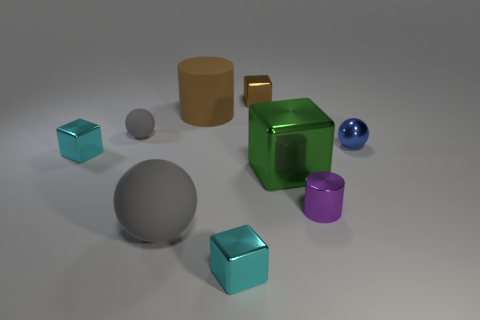Are there fewer brown cubes behind the tiny brown metallic block than green metal cubes?
Offer a very short reply. Yes. What number of tiny metal objects are the same color as the large cube?
Provide a short and direct response. 0. What is the size of the cyan block behind the small purple metal cylinder?
Ensure brevity in your answer.  Small. What shape is the big matte object that is in front of the blue metal sphere that is behind the tiny metal block that is left of the small gray sphere?
Make the answer very short. Sphere. There is a large thing that is both to the left of the green metal thing and in front of the small gray rubber sphere; what shape is it?
Give a very brief answer. Sphere. Is there a gray rubber sphere of the same size as the green metal cube?
Provide a succinct answer. Yes. Does the tiny cyan object that is right of the brown rubber cylinder have the same shape as the purple object?
Keep it short and to the point. No. Do the tiny brown thing and the large green thing have the same shape?
Provide a short and direct response. Yes. Are there any small metallic things of the same shape as the big green object?
Provide a short and direct response. Yes. There is a cyan object that is in front of the matte sphere in front of the purple cylinder; what is its shape?
Provide a short and direct response. Cube. 